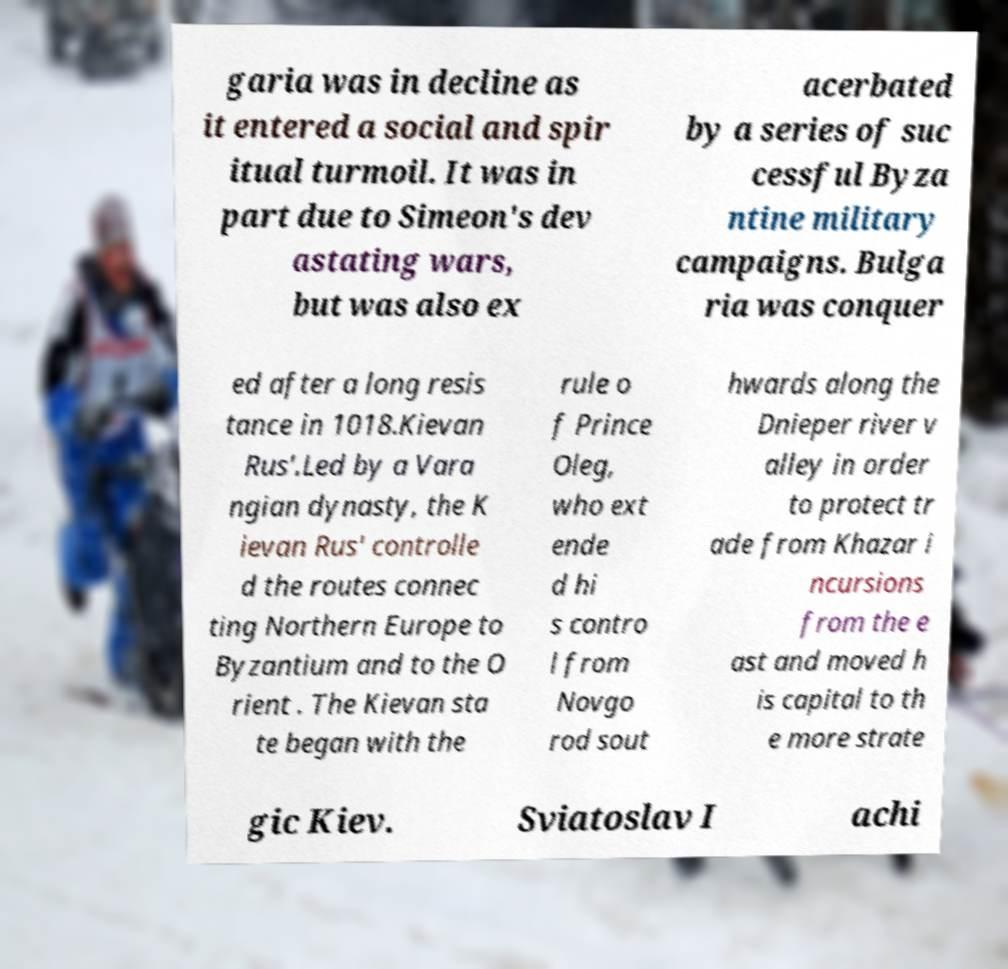I need the written content from this picture converted into text. Can you do that? garia was in decline as it entered a social and spir itual turmoil. It was in part due to Simeon's dev astating wars, but was also ex acerbated by a series of suc cessful Byza ntine military campaigns. Bulga ria was conquer ed after a long resis tance in 1018.Kievan Rus'.Led by a Vara ngian dynasty, the K ievan Rus' controlle d the routes connec ting Northern Europe to Byzantium and to the O rient . The Kievan sta te began with the rule o f Prince Oleg, who ext ende d hi s contro l from Novgo rod sout hwards along the Dnieper river v alley in order to protect tr ade from Khazar i ncursions from the e ast and moved h is capital to th e more strate gic Kiev. Sviatoslav I achi 